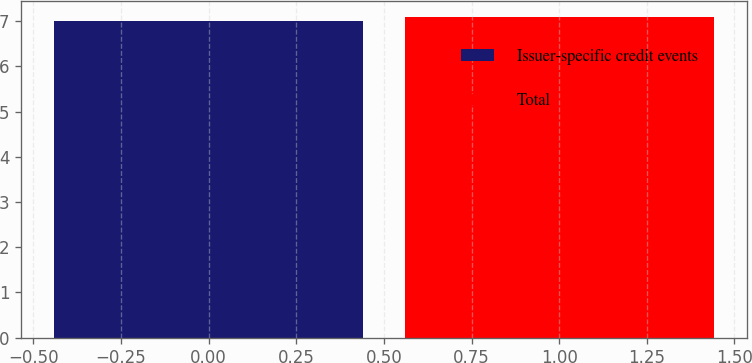Convert chart. <chart><loc_0><loc_0><loc_500><loc_500><bar_chart><fcel>Issuer-specific credit events<fcel>Total<nl><fcel>7<fcel>7.1<nl></chart> 